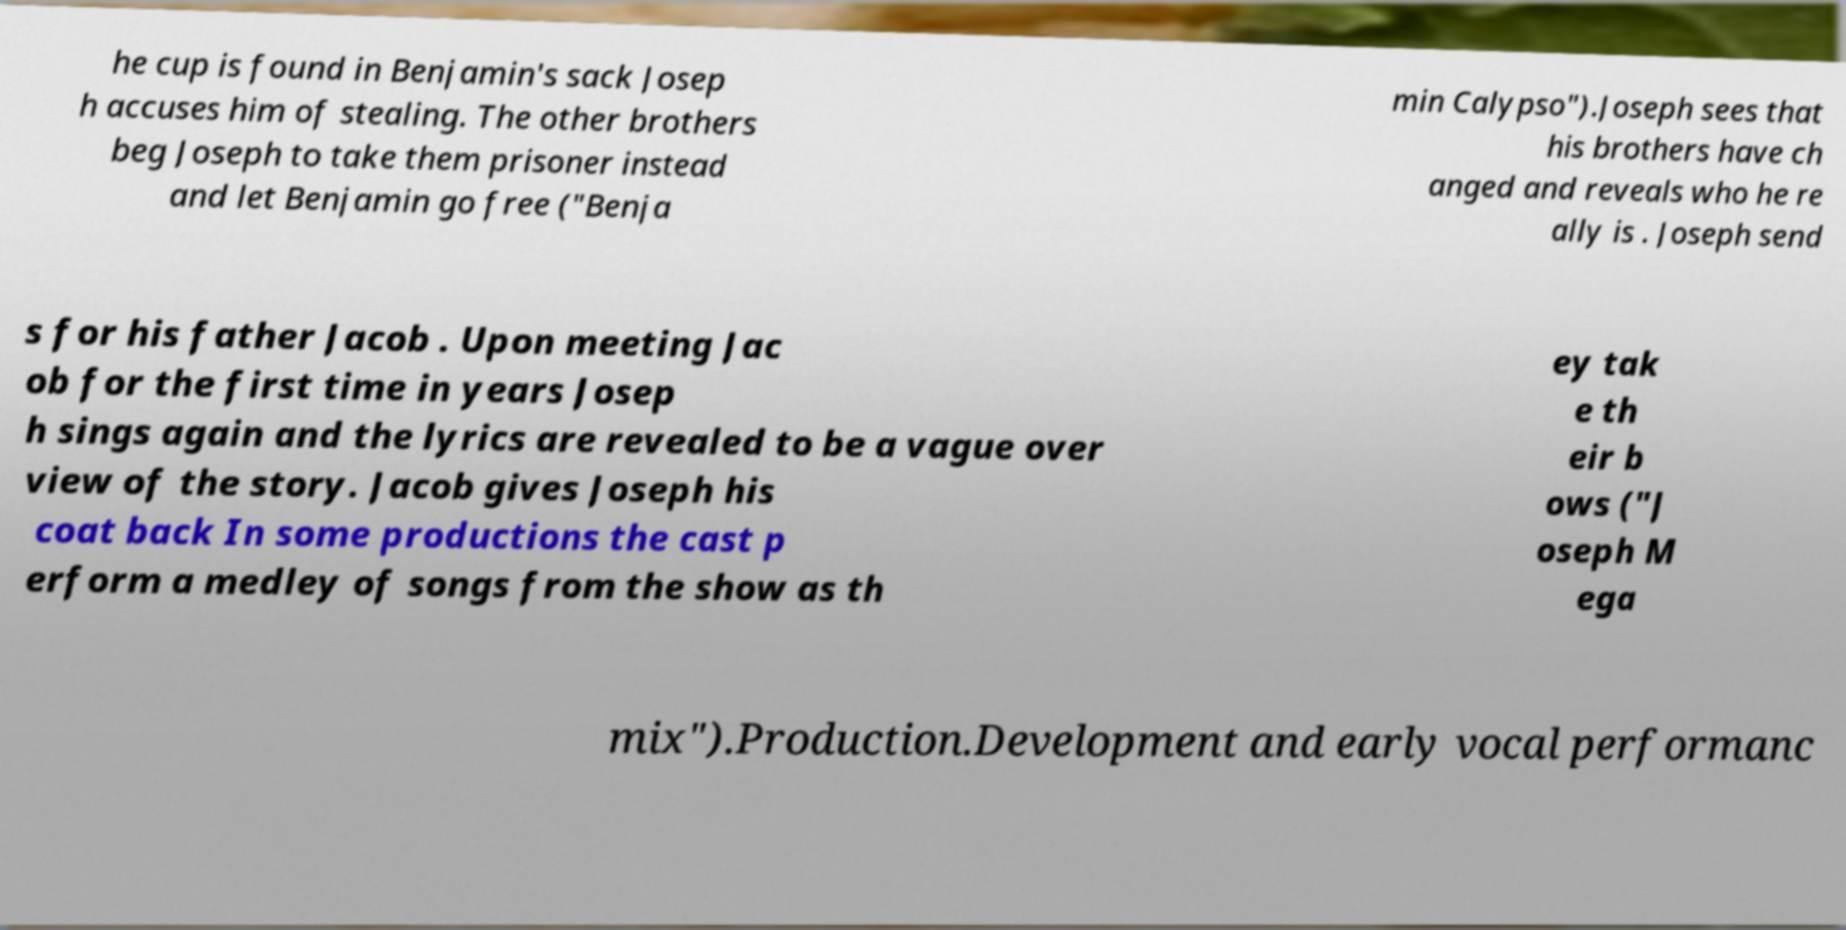Please identify and transcribe the text found in this image. he cup is found in Benjamin's sack Josep h accuses him of stealing. The other brothers beg Joseph to take them prisoner instead and let Benjamin go free ("Benja min Calypso").Joseph sees that his brothers have ch anged and reveals who he re ally is . Joseph send s for his father Jacob . Upon meeting Jac ob for the first time in years Josep h sings again and the lyrics are revealed to be a vague over view of the story. Jacob gives Joseph his coat back In some productions the cast p erform a medley of songs from the show as th ey tak e th eir b ows ("J oseph M ega mix").Production.Development and early vocal performanc 